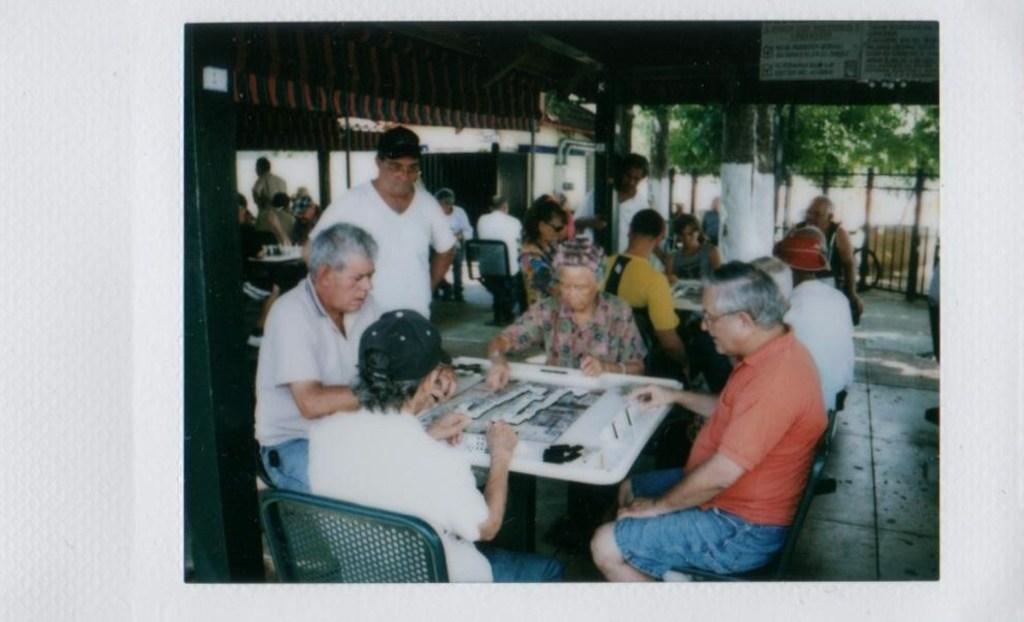What are the people in the image doing? The people in the image are sitting on chairs at a table. What can be seen in the background of the image? There are poles, trees, and a wall in the background of the image. What type of gold object is visible on the table in the image? There is no gold object present on the table in the image. What type of breakfast is being served at the table in the image? The image does not show any food or breakfast being served; it only shows people sitting at a table. 